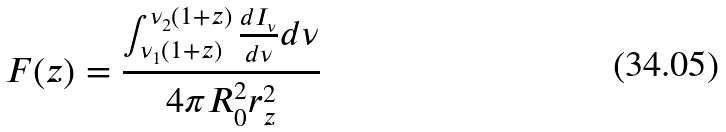Convert formula to latex. <formula><loc_0><loc_0><loc_500><loc_500>F ( z ) = \frac { \int _ { \nu _ { 1 } ( 1 + z ) } ^ { \nu _ { 2 } ( 1 + z ) } \frac { d I _ { \nu } } { d \nu } d \nu } { 4 \pi R _ { 0 } ^ { 2 } r _ { z } ^ { 2 } }</formula> 